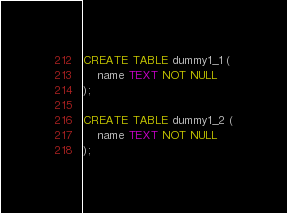Convert code to text. <code><loc_0><loc_0><loc_500><loc_500><_SQL_>CREATE TABLE dummy1_1 (
    name TEXT NOT NULL
);

CREATE TABLE dummy1_2 (
    name TEXT NOT NULL
);
</code> 